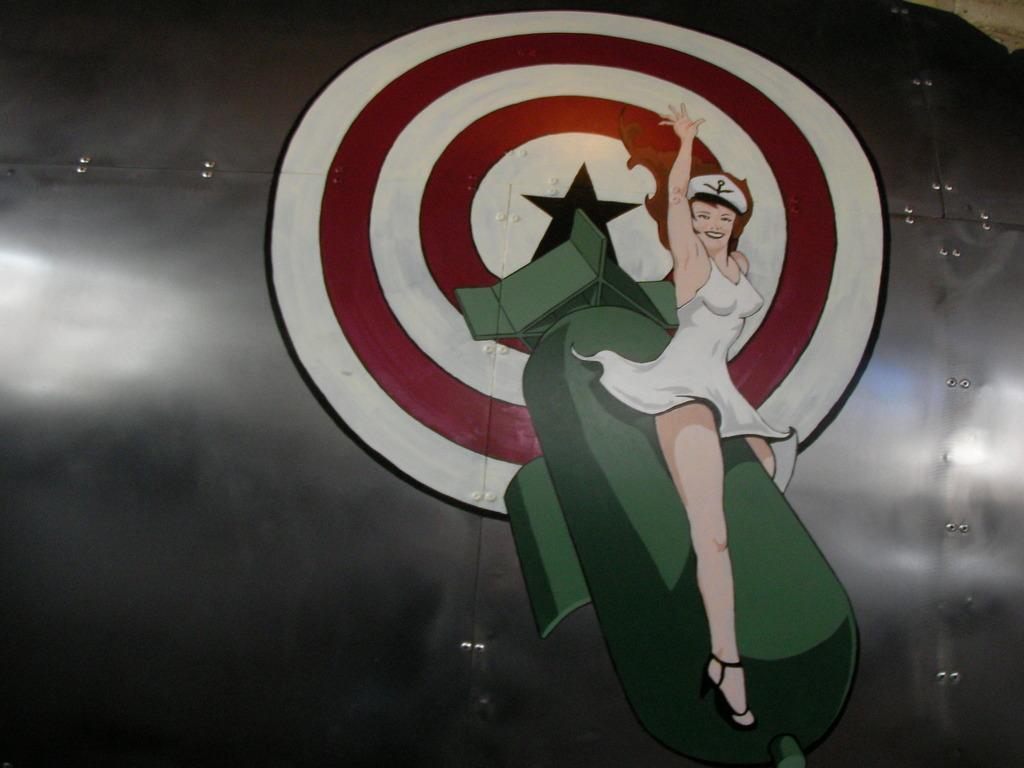What is the main subject of the image? There is a person in the image. What is the person doing in the image? The person is sitting on a rocket. What is the color of the surface the rocket is on? The rocket is on a black color surface. What type of lamp is hanging from the rocket in the image? There is no lamp present in the image; the person is sitting on a rocket on a black surface. 